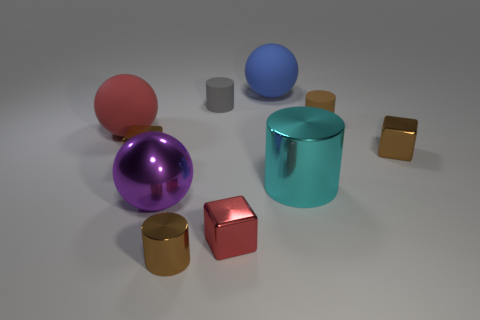Subtract all gray spheres. How many brown cylinders are left? 2 Subtract all big rubber balls. How many balls are left? 1 Subtract 1 blocks. How many blocks are left? 2 Subtract all red cubes. How many cubes are left? 2 Subtract all cylinders. How many objects are left? 6 Subtract all blue cylinders. Subtract all green balls. How many cylinders are left? 4 Subtract all large purple metallic balls. Subtract all cyan shiny cylinders. How many objects are left? 8 Add 8 brown metallic cubes. How many brown metallic cubes are left? 10 Add 8 red metallic objects. How many red metallic objects exist? 9 Subtract 0 cyan cubes. How many objects are left? 10 